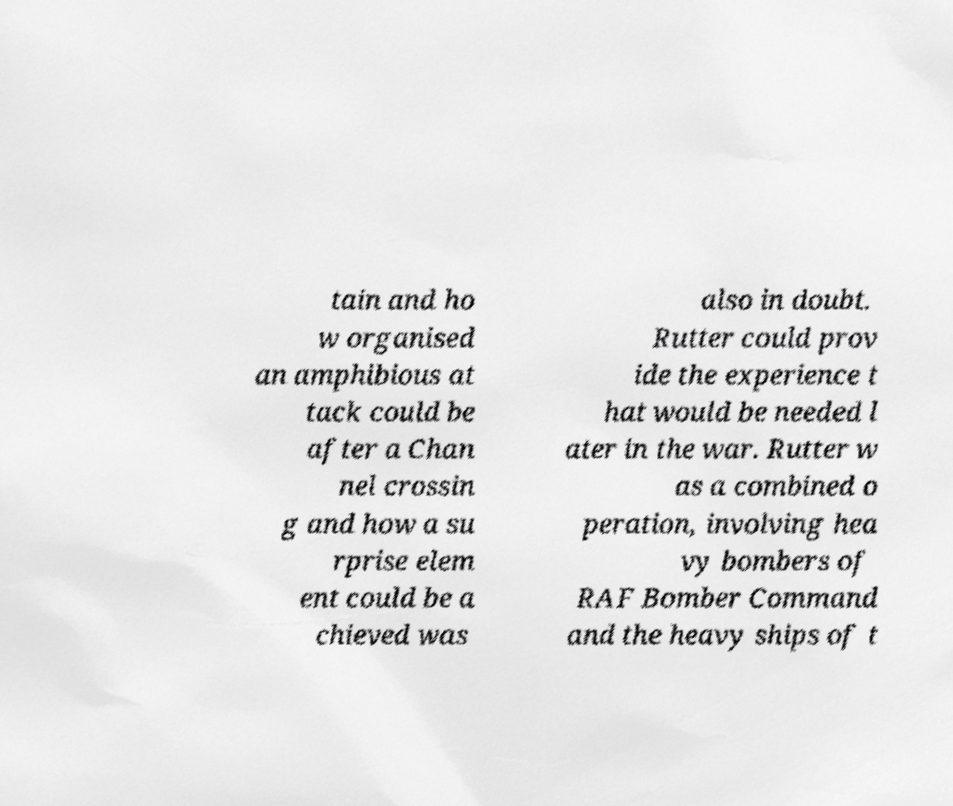Can you read and provide the text displayed in the image?This photo seems to have some interesting text. Can you extract and type it out for me? tain and ho w organised an amphibious at tack could be after a Chan nel crossin g and how a su rprise elem ent could be a chieved was also in doubt. Rutter could prov ide the experience t hat would be needed l ater in the war. Rutter w as a combined o peration, involving hea vy bombers of RAF Bomber Command and the heavy ships of t 